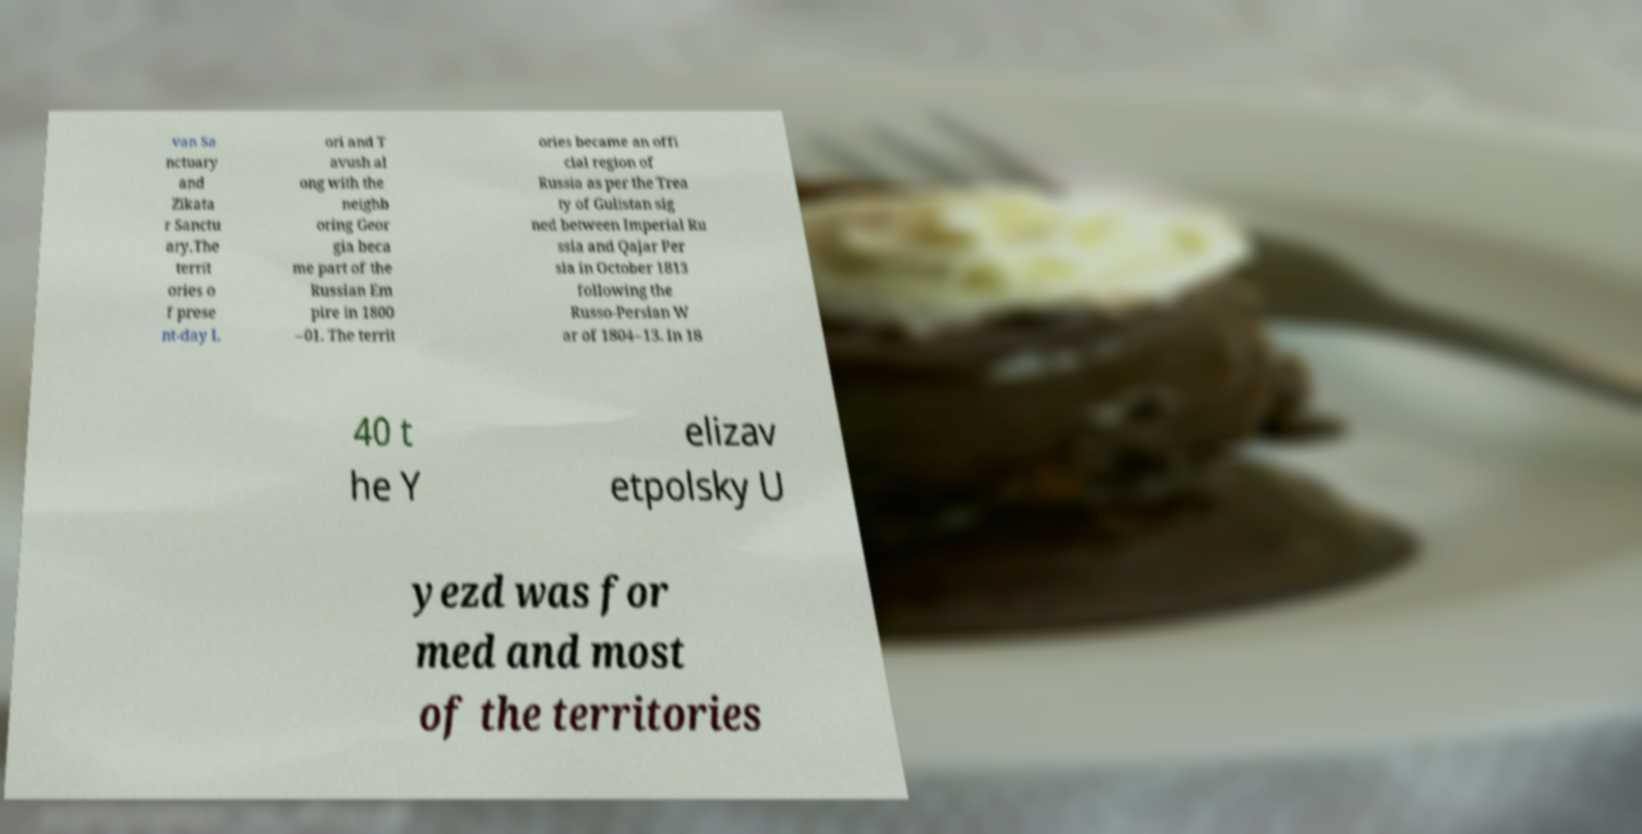Could you extract and type out the text from this image? van Sa nctuary and Zikata r Sanctu ary.The territ ories o f prese nt-day L ori and T avush al ong with the neighb oring Geor gia beca me part of the Russian Em pire in 1800 –01. The territ ories became an offi cial region of Russia as per the Trea ty of Gulistan sig ned between Imperial Ru ssia and Qajar Per sia in October 1813 following the Russo-Persian W ar of 1804–13. In 18 40 t he Y elizav etpolsky U yezd was for med and most of the territories 